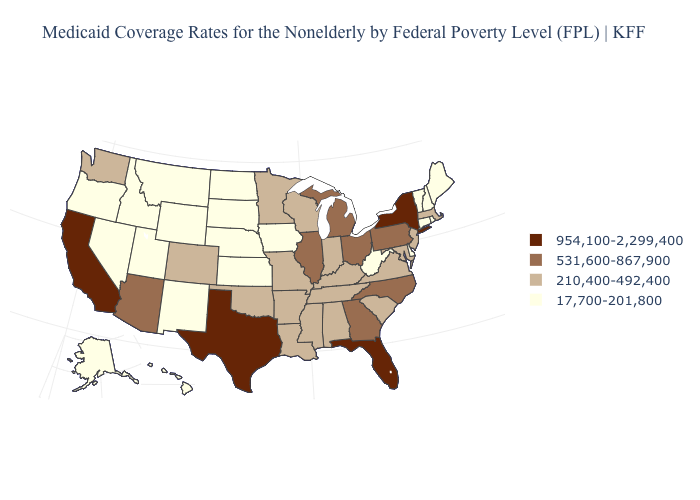Does Kentucky have the highest value in the USA?
Write a very short answer. No. Is the legend a continuous bar?
Be succinct. No. What is the value of Indiana?
Concise answer only. 210,400-492,400. Name the states that have a value in the range 954,100-2,299,400?
Write a very short answer. California, Florida, New York, Texas. Name the states that have a value in the range 531,600-867,900?
Concise answer only. Arizona, Georgia, Illinois, Michigan, North Carolina, Ohio, Pennsylvania. What is the value of New York?
Give a very brief answer. 954,100-2,299,400. Which states hav the highest value in the MidWest?
Be succinct. Illinois, Michigan, Ohio. Among the states that border South Dakota , which have the lowest value?
Quick response, please. Iowa, Montana, Nebraska, North Dakota, Wyoming. What is the value of Colorado?
Short answer required. 210,400-492,400. What is the highest value in the Northeast ?
Short answer required. 954,100-2,299,400. What is the highest value in states that border Minnesota?
Keep it brief. 210,400-492,400. Among the states that border Indiana , which have the lowest value?
Concise answer only. Kentucky. What is the value of Utah?
Give a very brief answer. 17,700-201,800. Is the legend a continuous bar?
Keep it brief. No. What is the highest value in states that border Missouri?
Give a very brief answer. 531,600-867,900. 